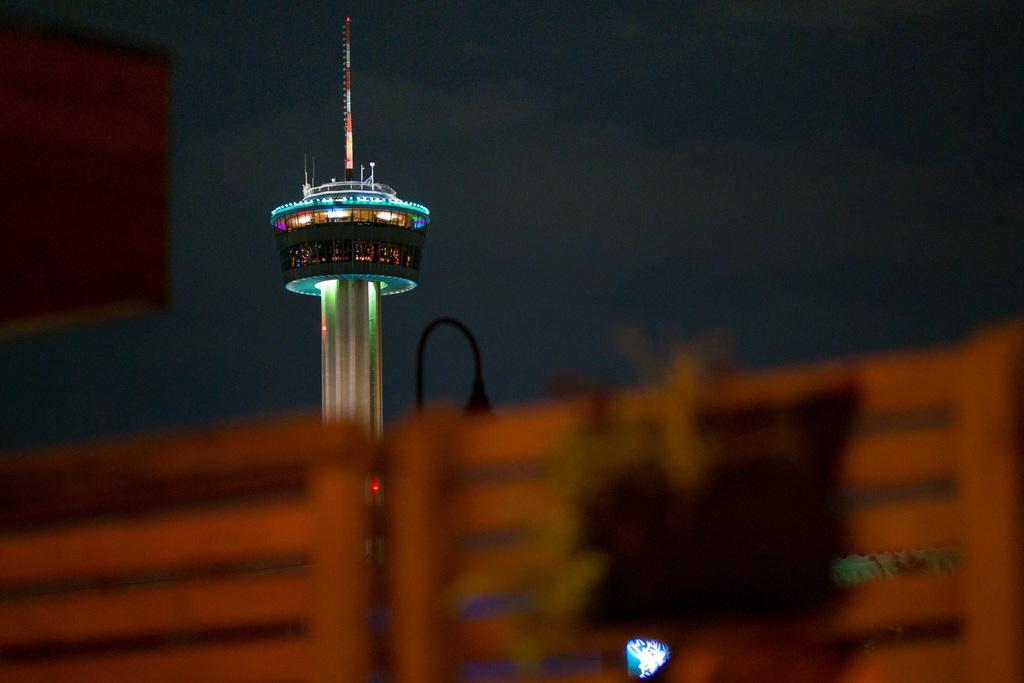Can you describe this image briefly? In the center of the image we can see tower and lights. At the bottom of the image we can see chairs. At the top of the image we can see the sky. 